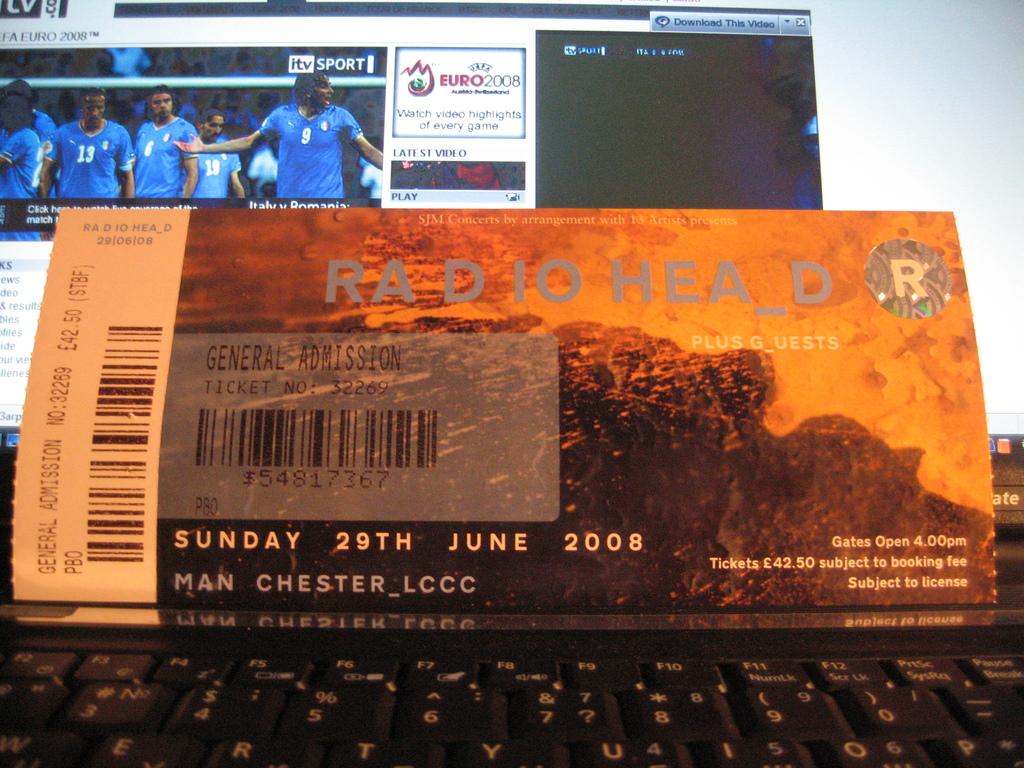How much did this radiohead ticket cost?
Your response must be concise. 42.50. What year was this concert?
Give a very brief answer. 2008. 